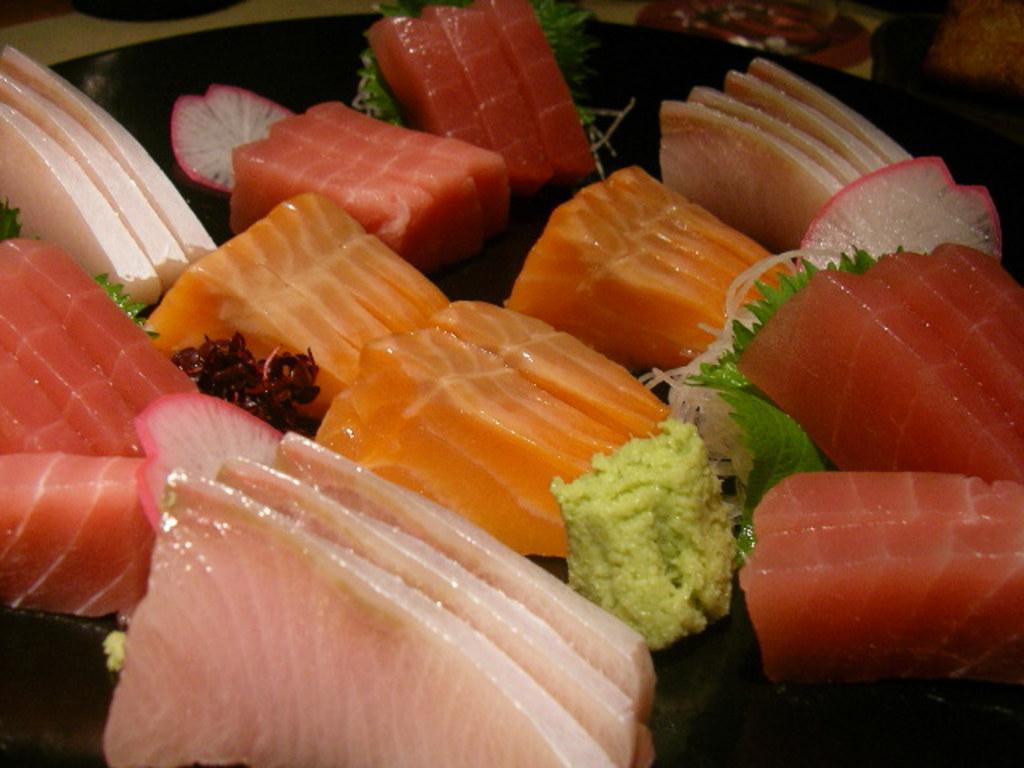Could you give a brief overview of what you see in this image? The picture consist of meat, served in a plate as a dish and there are other food items also. 